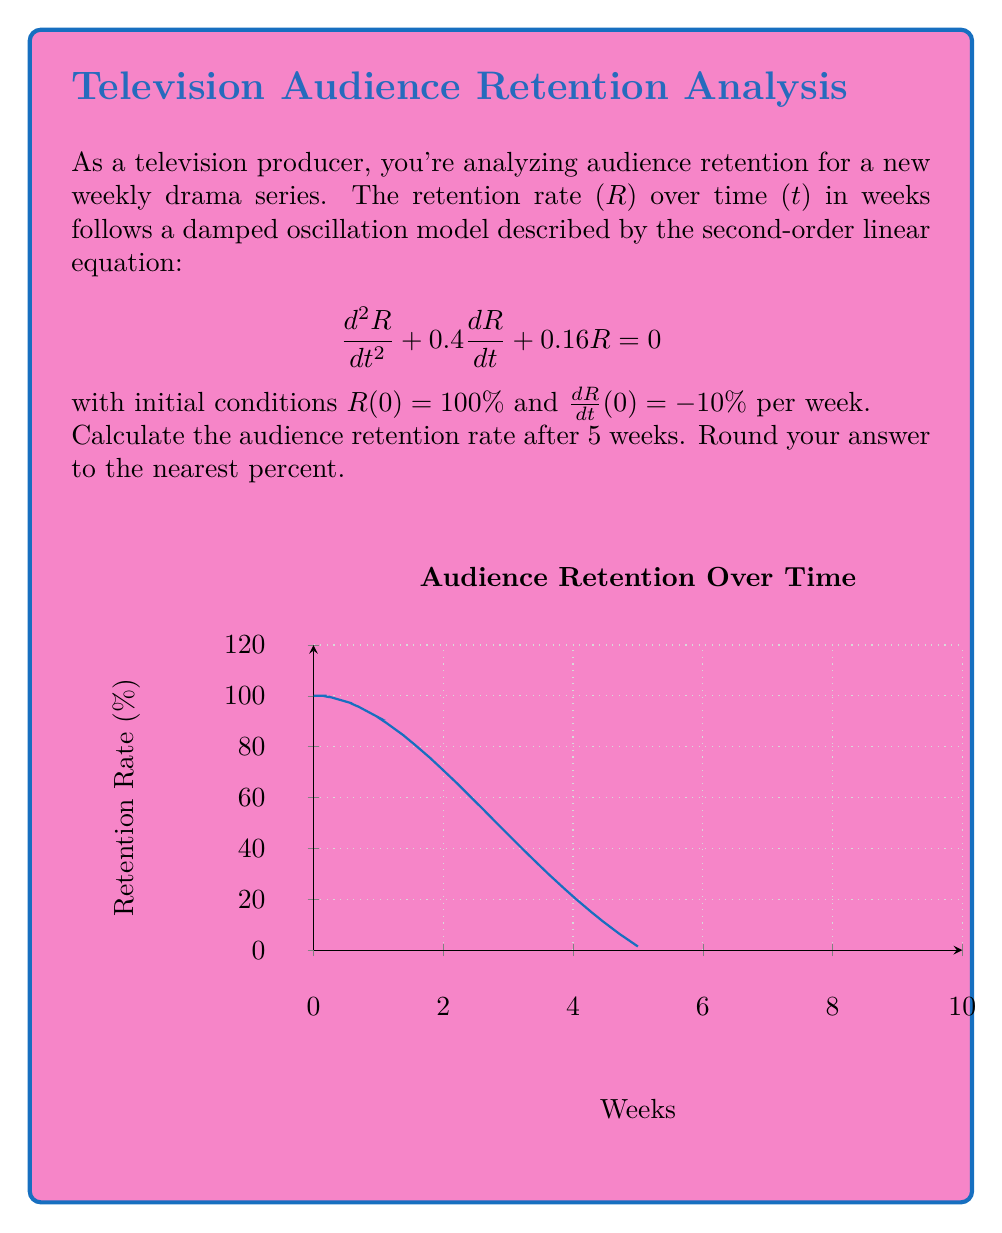Give your solution to this math problem. Let's solve this step-by-step:

1) The general solution for this damped oscillation equation is:
   $$R(t) = e^{-at}(A\cos(bt) + B\sin(bt))$$
   where $a = 0.2$ and $b = 0.4$ (from the characteristic equation).

2) Using the initial condition $R(0) = 100\%$:
   $$100 = A$$

3) The derivative of the general solution is:
   $$\frac{dR}{dt} = -ae^{-at}(A\cos(bt) + B\sin(bt)) + e^{-at}(-Ab\sin(bt) + Bb\cos(bt))$$

4) Using the initial condition $\frac{dR}{dt}(0) = -10\%$:
   $$-10 = -0.2A + 0.4B$$
   $$-10 = -20 + 0.4B$$
   $$10 = 0.4B$$
   $$B = 25$$

5) Therefore, the specific solution is:
   $$R(t) = 100e^{-0.2t}(\cos(0.4t) + 0.25\sin(0.4t))$$

6) To find R(5), we substitute t = 5:
   $$R(5) = 100e^{-0.2(5)}(\cos(0.4(5)) + 0.25\sin(0.4(5)))$$
   $$= 100e^{-1}(\cos(2) + 0.25\sin(2))$$
   $$\approx 36.79 * (-0.4161 + 0.25 * 0.9093)$$
   $$\approx 36.79 * (-0.4161 + 0.2273)$$
   $$\approx 36.79 * (-0.1888)$$
   $$\approx -6.95\%$$

7) The negative value indicates that the retention rate has dropped below the initial value. To express this as a positive retention rate, we add 100%:
   $$100\% - 6.95\% = 93.05\%$$

8) Rounding to the nearest percent: 93%
Answer: 93% 